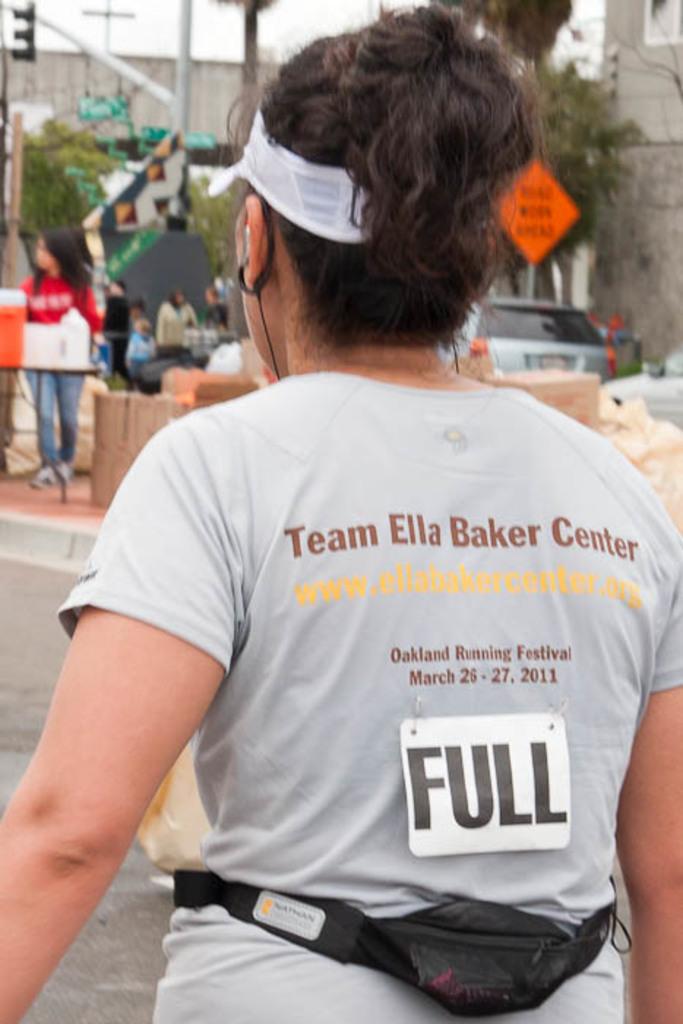What team is she a part of?
Ensure brevity in your answer.  Ella baker center. 